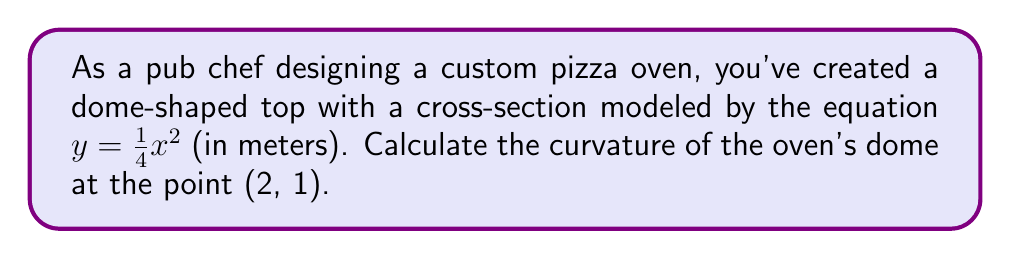Can you solve this math problem? Let's approach this step-by-step:

1) The curvature $\kappa$ of a curve $y = f(x)$ at a point is given by the formula:

   $$\kappa = \frac{|f''(x)|}{(1 + [f'(x)]^2)^{3/2}}$$

2) We need to find $f'(x)$ and $f''(x)$:
   
   $f(x) = \frac{1}{4}x^2$
   
   $f'(x) = \frac{1}{2}x$
   
   $f''(x) = \frac{1}{2}$

3) At the point (2, 1), $x = 2$. Let's substitute this into $f'(x)$:
   
   $f'(2) = \frac{1}{2}(2) = 1$

4) Now we can substitute these values into the curvature formula:

   $$\kappa = \frac{|\frac{1}{2}|}{(1 + [1]^2)^{3/2}}$$

5) Simplify:
   
   $$\kappa = \frac{0.5}{(1 + 1)^{3/2}} = \frac{0.5}{2^{3/2}} = \frac{0.5}{2\sqrt{2}}$$

6) Simplify further:
   
   $$\kappa = \frac{1}{4\sqrt{2}} \approx 0.1768 \text{ m}^{-1}$$
Answer: $\frac{1}{4\sqrt{2}}$ m$^{-1}$ 